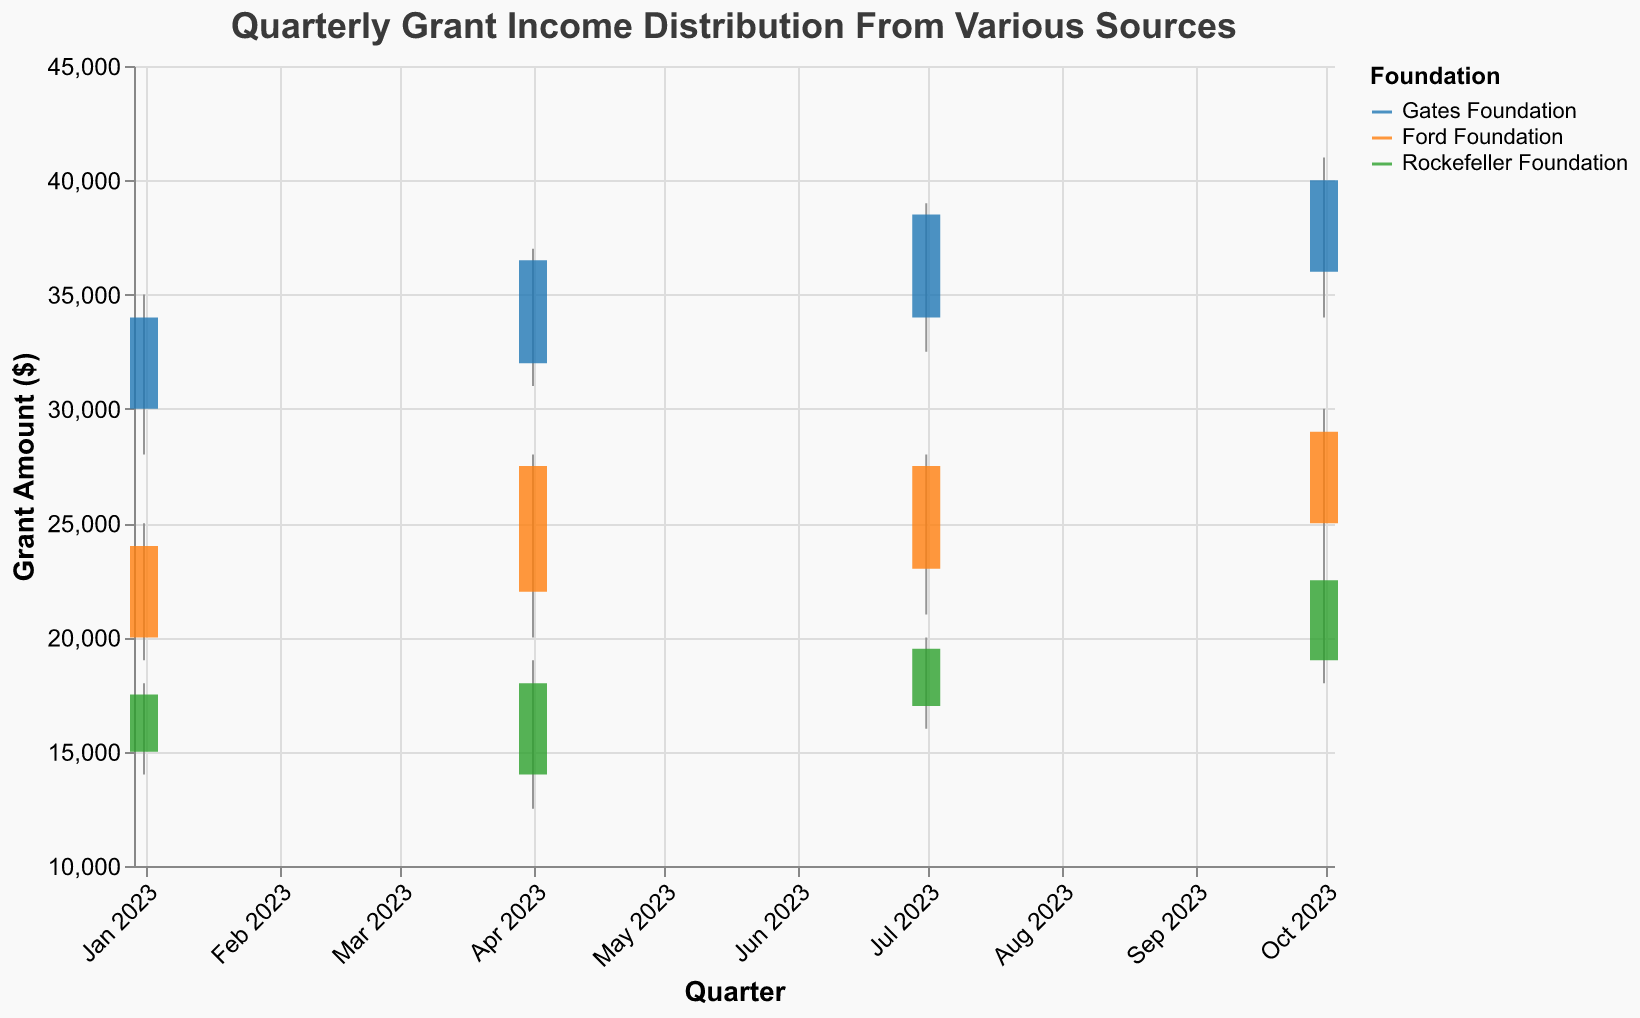What is the title of the chart? The title of the chart is located at the top of the figure and is visually distinctive due to its larger font size and bold styling.
Answer: Quarterly Grant Income Distribution From Various Sources What is the grant amount range for the Ford Foundation in Q3 2023? To find the grant amount range, identify the 'High' and 'Low' values for the Ford Foundation in Q3 2023 (July). The high is 28000 and the low is 21000.
Answer: 21000 - 28000 Which foundation had the highest closing amount in Q4 2023? Look at the 'Close' values for Q4 2023 (October) for each foundation. The Gates Foundation has the highest closing amount at 40000.
Answer: Gates Foundation By how much did the Rockefeller Foundation's closing amount increase from Q2 to Q3 2023? Identify the closing amounts for the Rockefeller Foundation in Q2 2023 (April) and Q3 2023 (July). The close amount increased from 18000 to 19500. The increase is calculated as 19500 - 18000 = 1500.
Answer: 1500 What is the median closing grant amount in Q3 2023 across all foundations? First, find the closing grant amounts in Q3 2023 (July) for all foundations: Gates Foundation (38500), Ford Foundation (27500), Rockefeller Foundation (19500). Arrange them in ascending order: 19500, 27500, 38500. The median value is the middle one: 27500.
Answer: 27500 Which foundation shows the largest overall increase in the closing amount from Q1 to Q4 2023? Calculate the increase for each foundation from Q1 to Q4 2023 by subtracting Q1's closing amount from Q4's closing amount. 
- Gates Foundation: 40000 - 34000 = 6000
- Ford Foundation: 29000 - 24000 = 5000
- Rockefeller Foundation: 22500 - 17500 = 5000
The largest increase is for the Gates Foundation.
Answer: Gates Foundation How many foundations showed a closing amount above 35000 in Q4 2023? Look at the closing amounts for Q4 2023 (October) for each foundation and count those above 35000. The Gates Foundation is the only one with a closing amount above 35000 (40000).
Answer: 1 Between which quarters did the Ford Foundation experience the highest increase in closing amount? Observe the closing amounts for the Ford Foundation in each quarter: Q1 (24000), Q2 (27500), Q3 (27500), Q4 (29000). 
Calculate the increases:
- Q1 to Q2: 27500 - 24000 = 3500
- Q2 to Q3: 27500 - 27500 = 0
- Q3 to Q4: 29000 - 27500 = 1500
The highest increase occurred from Q1 to Q2.
Answer: Q1 to Q2 